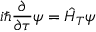<formula> <loc_0><loc_0><loc_500><loc_500>i \hbar { } \partial } { \partial \tau } \psi = \hat { H } _ { T } \psi</formula> 